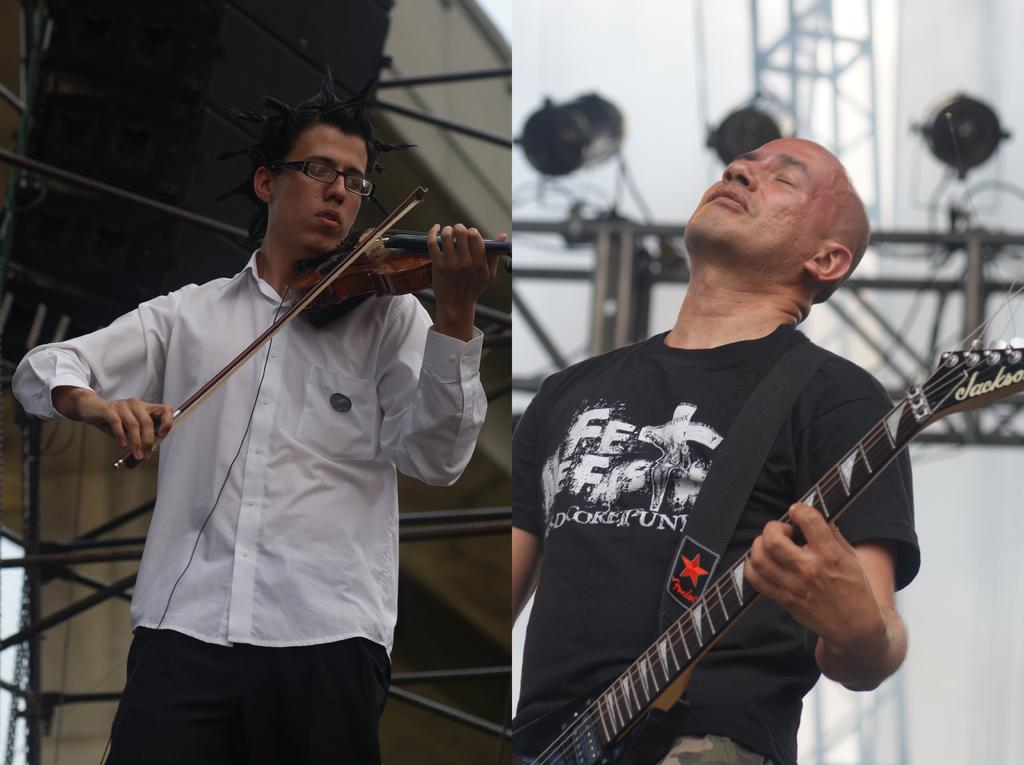How many people are in the image? There are two people in the image. What are the people doing in the image? Both people are standing and playing musical instruments. What type of rock can be seen falling during the rainstorm in the image? There is no rock or rainstorm present in the image; it features two people playing musical instruments while standing. 